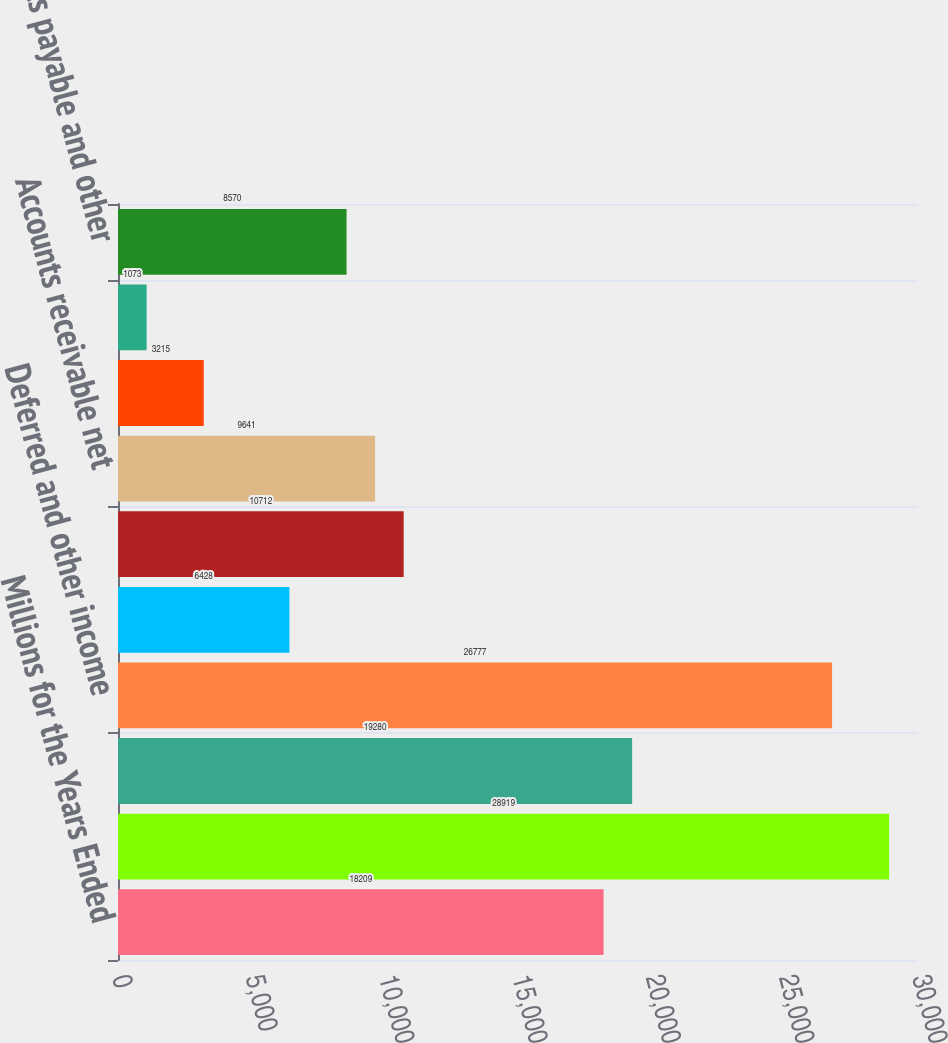Convert chart. <chart><loc_0><loc_0><loc_500><loc_500><bar_chart><fcel>Millions for the Years Ended<fcel>Net income<fcel>Depreciation<fcel>Deferred and other income<fcel>Net gain on non-operating<fcel>Other operating activities net<fcel>Accounts receivable net<fcel>Materials and supplies<fcel>Other current assets<fcel>Accounts payable and other<nl><fcel>18209<fcel>28919<fcel>19280<fcel>26777<fcel>6428<fcel>10712<fcel>9641<fcel>3215<fcel>1073<fcel>8570<nl></chart> 